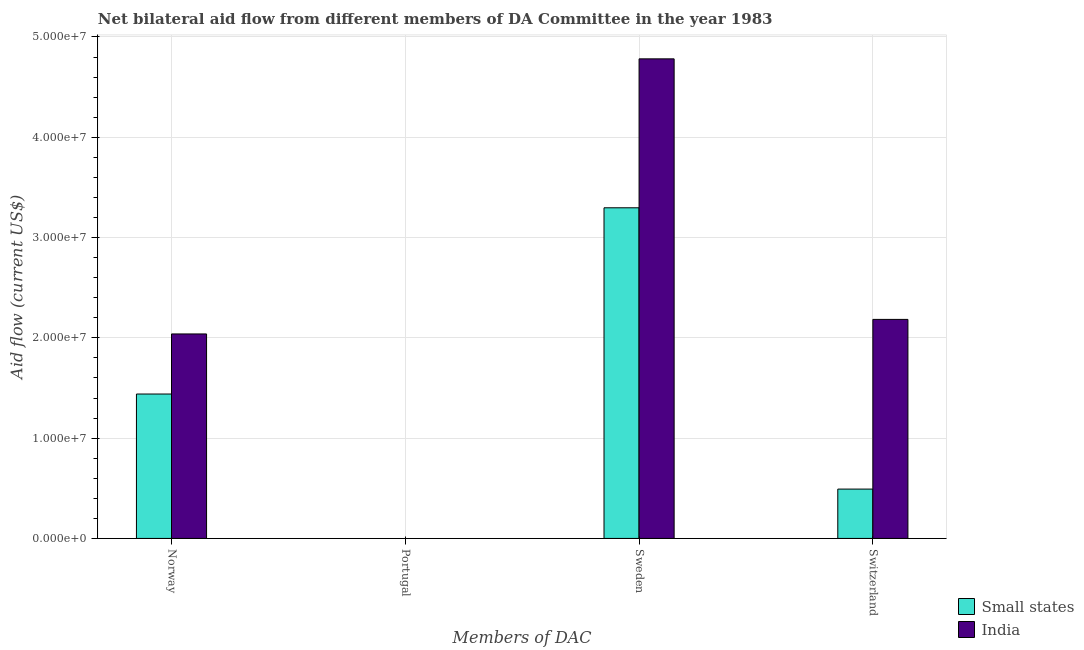Are the number of bars on each tick of the X-axis equal?
Your response must be concise. No. How many bars are there on the 3rd tick from the right?
Your answer should be very brief. 0. What is the label of the 1st group of bars from the left?
Offer a very short reply. Norway. What is the amount of aid given by norway in Small states?
Your answer should be compact. 1.44e+07. Across all countries, what is the maximum amount of aid given by switzerland?
Give a very brief answer. 2.18e+07. Across all countries, what is the minimum amount of aid given by sweden?
Offer a very short reply. 3.30e+07. What is the total amount of aid given by sweden in the graph?
Keep it short and to the point. 8.08e+07. What is the difference between the amount of aid given by norway in Small states and that in India?
Make the answer very short. -5.99e+06. What is the difference between the amount of aid given by portugal in India and the amount of aid given by norway in Small states?
Your answer should be very brief. -1.44e+07. What is the average amount of aid given by norway per country?
Ensure brevity in your answer.  1.74e+07. What is the difference between the amount of aid given by sweden and amount of aid given by norway in India?
Keep it short and to the point. 2.74e+07. In how many countries, is the amount of aid given by sweden greater than 34000000 US$?
Your answer should be compact. 1. What is the ratio of the amount of aid given by norway in Small states to that in India?
Provide a succinct answer. 0.71. Is the amount of aid given by norway in India less than that in Small states?
Your answer should be compact. No. What is the difference between the highest and the second highest amount of aid given by switzerland?
Your answer should be compact. 1.69e+07. What is the difference between the highest and the lowest amount of aid given by switzerland?
Give a very brief answer. 1.69e+07. Is it the case that in every country, the sum of the amount of aid given by norway and amount of aid given by portugal is greater than the amount of aid given by sweden?
Offer a very short reply. No. Are all the bars in the graph horizontal?
Your answer should be very brief. No. Are the values on the major ticks of Y-axis written in scientific E-notation?
Offer a very short reply. Yes. How are the legend labels stacked?
Make the answer very short. Vertical. What is the title of the graph?
Make the answer very short. Net bilateral aid flow from different members of DA Committee in the year 1983. What is the label or title of the X-axis?
Your response must be concise. Members of DAC. What is the Aid flow (current US$) in Small states in Norway?
Offer a very short reply. 1.44e+07. What is the Aid flow (current US$) of India in Norway?
Ensure brevity in your answer.  2.04e+07. What is the Aid flow (current US$) in Small states in Portugal?
Your answer should be compact. Nan. What is the Aid flow (current US$) in India in Portugal?
Your answer should be compact. Nan. What is the Aid flow (current US$) in Small states in Sweden?
Provide a succinct answer. 3.30e+07. What is the Aid flow (current US$) of India in Sweden?
Provide a succinct answer. 4.78e+07. What is the Aid flow (current US$) in Small states in Switzerland?
Offer a very short reply. 4.92e+06. What is the Aid flow (current US$) in India in Switzerland?
Ensure brevity in your answer.  2.18e+07. Across all Members of DAC, what is the maximum Aid flow (current US$) of Small states?
Offer a very short reply. 3.30e+07. Across all Members of DAC, what is the maximum Aid flow (current US$) in India?
Ensure brevity in your answer.  4.78e+07. Across all Members of DAC, what is the minimum Aid flow (current US$) of Small states?
Keep it short and to the point. 4.92e+06. Across all Members of DAC, what is the minimum Aid flow (current US$) of India?
Your answer should be very brief. 2.04e+07. What is the total Aid flow (current US$) in Small states in the graph?
Ensure brevity in your answer.  5.23e+07. What is the total Aid flow (current US$) of India in the graph?
Your answer should be very brief. 9.00e+07. What is the difference between the Aid flow (current US$) in Small states in Norway and that in Portugal?
Ensure brevity in your answer.  Nan. What is the difference between the Aid flow (current US$) in India in Norway and that in Portugal?
Your response must be concise. Nan. What is the difference between the Aid flow (current US$) of Small states in Norway and that in Sweden?
Ensure brevity in your answer.  -1.86e+07. What is the difference between the Aid flow (current US$) of India in Norway and that in Sweden?
Offer a very short reply. -2.74e+07. What is the difference between the Aid flow (current US$) of Small states in Norway and that in Switzerland?
Give a very brief answer. 9.48e+06. What is the difference between the Aid flow (current US$) of India in Norway and that in Switzerland?
Provide a succinct answer. -1.45e+06. What is the difference between the Aid flow (current US$) of Small states in Portugal and that in Sweden?
Provide a short and direct response. Nan. What is the difference between the Aid flow (current US$) in India in Portugal and that in Sweden?
Your response must be concise. Nan. What is the difference between the Aid flow (current US$) in Small states in Portugal and that in Switzerland?
Make the answer very short. Nan. What is the difference between the Aid flow (current US$) in India in Portugal and that in Switzerland?
Give a very brief answer. Nan. What is the difference between the Aid flow (current US$) in Small states in Sweden and that in Switzerland?
Provide a succinct answer. 2.80e+07. What is the difference between the Aid flow (current US$) of India in Sweden and that in Switzerland?
Provide a succinct answer. 2.60e+07. What is the difference between the Aid flow (current US$) in Small states in Norway and the Aid flow (current US$) in India in Portugal?
Offer a terse response. Nan. What is the difference between the Aid flow (current US$) in Small states in Norway and the Aid flow (current US$) in India in Sweden?
Provide a short and direct response. -3.34e+07. What is the difference between the Aid flow (current US$) of Small states in Norway and the Aid flow (current US$) of India in Switzerland?
Make the answer very short. -7.44e+06. What is the difference between the Aid flow (current US$) of Small states in Portugal and the Aid flow (current US$) of India in Sweden?
Provide a succinct answer. Nan. What is the difference between the Aid flow (current US$) in Small states in Portugal and the Aid flow (current US$) in India in Switzerland?
Your response must be concise. Nan. What is the difference between the Aid flow (current US$) in Small states in Sweden and the Aid flow (current US$) in India in Switzerland?
Offer a very short reply. 1.11e+07. What is the average Aid flow (current US$) of Small states per Members of DAC?
Keep it short and to the point. 1.31e+07. What is the average Aid flow (current US$) in India per Members of DAC?
Your answer should be compact. 2.25e+07. What is the difference between the Aid flow (current US$) of Small states and Aid flow (current US$) of India in Norway?
Provide a succinct answer. -5.99e+06. What is the difference between the Aid flow (current US$) of Small states and Aid flow (current US$) of India in Portugal?
Your answer should be very brief. Nan. What is the difference between the Aid flow (current US$) of Small states and Aid flow (current US$) of India in Sweden?
Your answer should be compact. -1.48e+07. What is the difference between the Aid flow (current US$) of Small states and Aid flow (current US$) of India in Switzerland?
Provide a succinct answer. -1.69e+07. What is the ratio of the Aid flow (current US$) of Small states in Norway to that in Portugal?
Your response must be concise. Nan. What is the ratio of the Aid flow (current US$) of India in Norway to that in Portugal?
Provide a short and direct response. Nan. What is the ratio of the Aid flow (current US$) in Small states in Norway to that in Sweden?
Provide a short and direct response. 0.44. What is the ratio of the Aid flow (current US$) of India in Norway to that in Sweden?
Offer a terse response. 0.43. What is the ratio of the Aid flow (current US$) in Small states in Norway to that in Switzerland?
Your answer should be compact. 2.93. What is the ratio of the Aid flow (current US$) of India in Norway to that in Switzerland?
Your answer should be compact. 0.93. What is the ratio of the Aid flow (current US$) in Small states in Portugal to that in Sweden?
Your response must be concise. Nan. What is the ratio of the Aid flow (current US$) in India in Portugal to that in Sweden?
Keep it short and to the point. Nan. What is the ratio of the Aid flow (current US$) in Small states in Portugal to that in Switzerland?
Offer a terse response. Nan. What is the ratio of the Aid flow (current US$) in India in Portugal to that in Switzerland?
Provide a succinct answer. Nan. What is the ratio of the Aid flow (current US$) of Small states in Sweden to that in Switzerland?
Provide a short and direct response. 6.7. What is the ratio of the Aid flow (current US$) in India in Sweden to that in Switzerland?
Your answer should be very brief. 2.19. What is the difference between the highest and the second highest Aid flow (current US$) in Small states?
Provide a succinct answer. 1.86e+07. What is the difference between the highest and the second highest Aid flow (current US$) in India?
Provide a short and direct response. 2.60e+07. What is the difference between the highest and the lowest Aid flow (current US$) of Small states?
Offer a terse response. 2.80e+07. What is the difference between the highest and the lowest Aid flow (current US$) of India?
Give a very brief answer. 2.74e+07. 